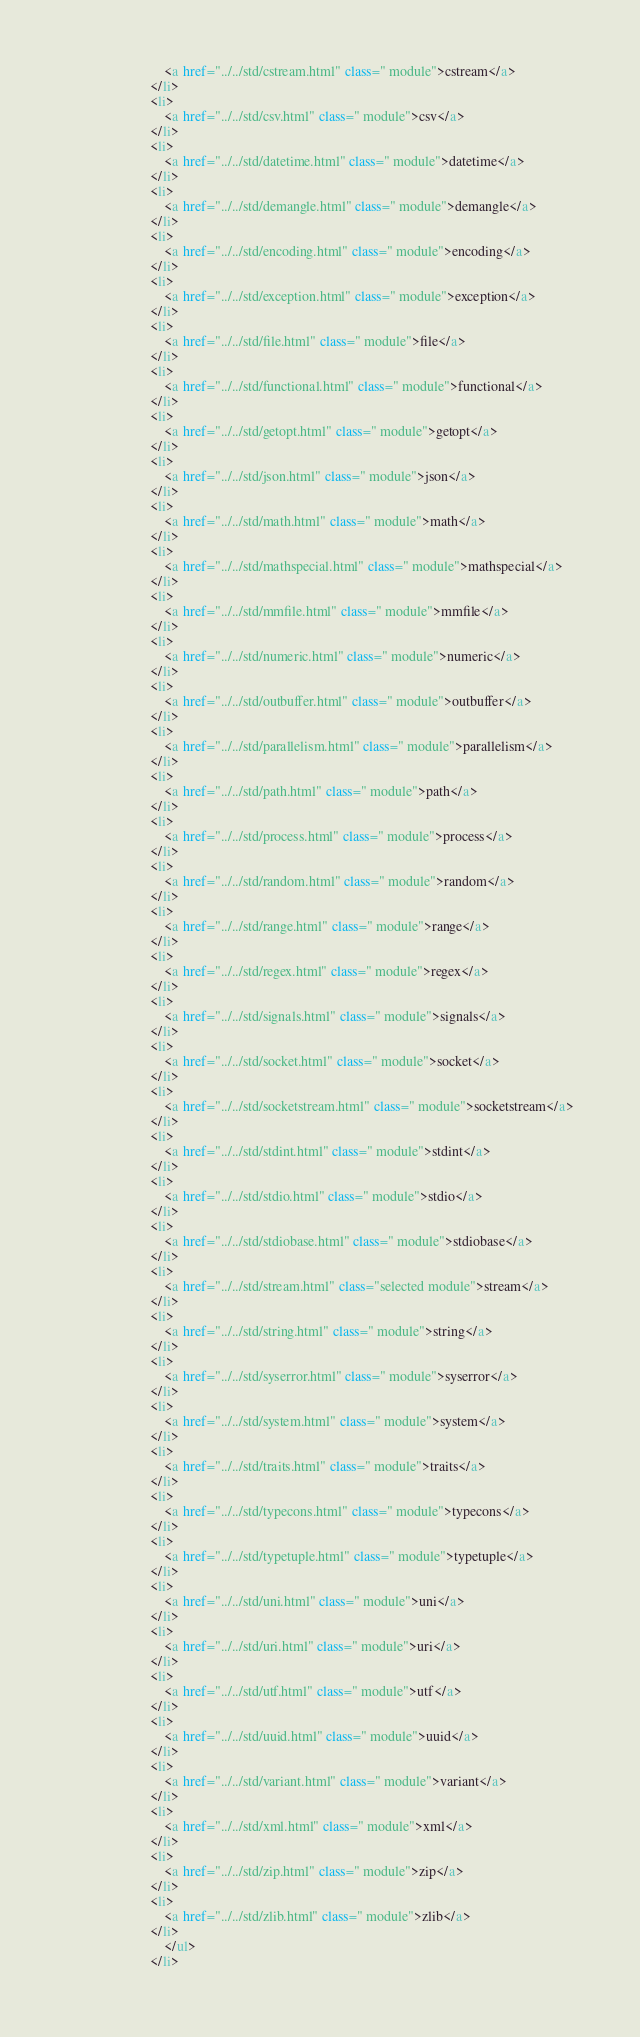Convert code to text. <code><loc_0><loc_0><loc_500><loc_500><_HTML_>							<a href="../../std/cstream.html" class=" module">cstream</a>
						</li>
						<li>
							<a href="../../std/csv.html" class=" module">csv</a>
						</li>
						<li>
							<a href="../../std/datetime.html" class=" module">datetime</a>
						</li>
						<li>
							<a href="../../std/demangle.html" class=" module">demangle</a>
						</li>
						<li>
							<a href="../../std/encoding.html" class=" module">encoding</a>
						</li>
						<li>
							<a href="../../std/exception.html" class=" module">exception</a>
						</li>
						<li>
							<a href="../../std/file.html" class=" module">file</a>
						</li>
						<li>
							<a href="../../std/functional.html" class=" module">functional</a>
						</li>
						<li>
							<a href="../../std/getopt.html" class=" module">getopt</a>
						</li>
						<li>
							<a href="../../std/json.html" class=" module">json</a>
						</li>
						<li>
							<a href="../../std/math.html" class=" module">math</a>
						</li>
						<li>
							<a href="../../std/mathspecial.html" class=" module">mathspecial</a>
						</li>
						<li>
							<a href="../../std/mmfile.html" class=" module">mmfile</a>
						</li>
						<li>
							<a href="../../std/numeric.html" class=" module">numeric</a>
						</li>
						<li>
							<a href="../../std/outbuffer.html" class=" module">outbuffer</a>
						</li>
						<li>
							<a href="../../std/parallelism.html" class=" module">parallelism</a>
						</li>
						<li>
							<a href="../../std/path.html" class=" module">path</a>
						</li>
						<li>
							<a href="../../std/process.html" class=" module">process</a>
						</li>
						<li>
							<a href="../../std/random.html" class=" module">random</a>
						</li>
						<li>
							<a href="../../std/range.html" class=" module">range</a>
						</li>
						<li>
							<a href="../../std/regex.html" class=" module">regex</a>
						</li>
						<li>
							<a href="../../std/signals.html" class=" module">signals</a>
						</li>
						<li>
							<a href="../../std/socket.html" class=" module">socket</a>
						</li>
						<li>
							<a href="../../std/socketstream.html" class=" module">socketstream</a>
						</li>
						<li>
							<a href="../../std/stdint.html" class=" module">stdint</a>
						</li>
						<li>
							<a href="../../std/stdio.html" class=" module">stdio</a>
						</li>
						<li>
							<a href="../../std/stdiobase.html" class=" module">stdiobase</a>
						</li>
						<li>
							<a href="../../std/stream.html" class="selected module">stream</a>
						</li>
						<li>
							<a href="../../std/string.html" class=" module">string</a>
						</li>
						<li>
							<a href="../../std/syserror.html" class=" module">syserror</a>
						</li>
						<li>
							<a href="../../std/system.html" class=" module">system</a>
						</li>
						<li>
							<a href="../../std/traits.html" class=" module">traits</a>
						</li>
						<li>
							<a href="../../std/typecons.html" class=" module">typecons</a>
						</li>
						<li>
							<a href="../../std/typetuple.html" class=" module">typetuple</a>
						</li>
						<li>
							<a href="../../std/uni.html" class=" module">uni</a>
						</li>
						<li>
							<a href="../../std/uri.html" class=" module">uri</a>
						</li>
						<li>
							<a href="../../std/utf.html" class=" module">utf</a>
						</li>
						<li>
							<a href="../../std/uuid.html" class=" module">uuid</a>
						</li>
						<li>
							<a href="../../std/variant.html" class=" module">variant</a>
						</li>
						<li>
							<a href="../../std/xml.html" class=" module">xml</a>
						</li>
						<li>
							<a href="../../std/zip.html" class=" module">zip</a>
						</li>
						<li>
							<a href="../../std/zlib.html" class=" module">zlib</a>
						</li>
							</ul>
						</li></code> 